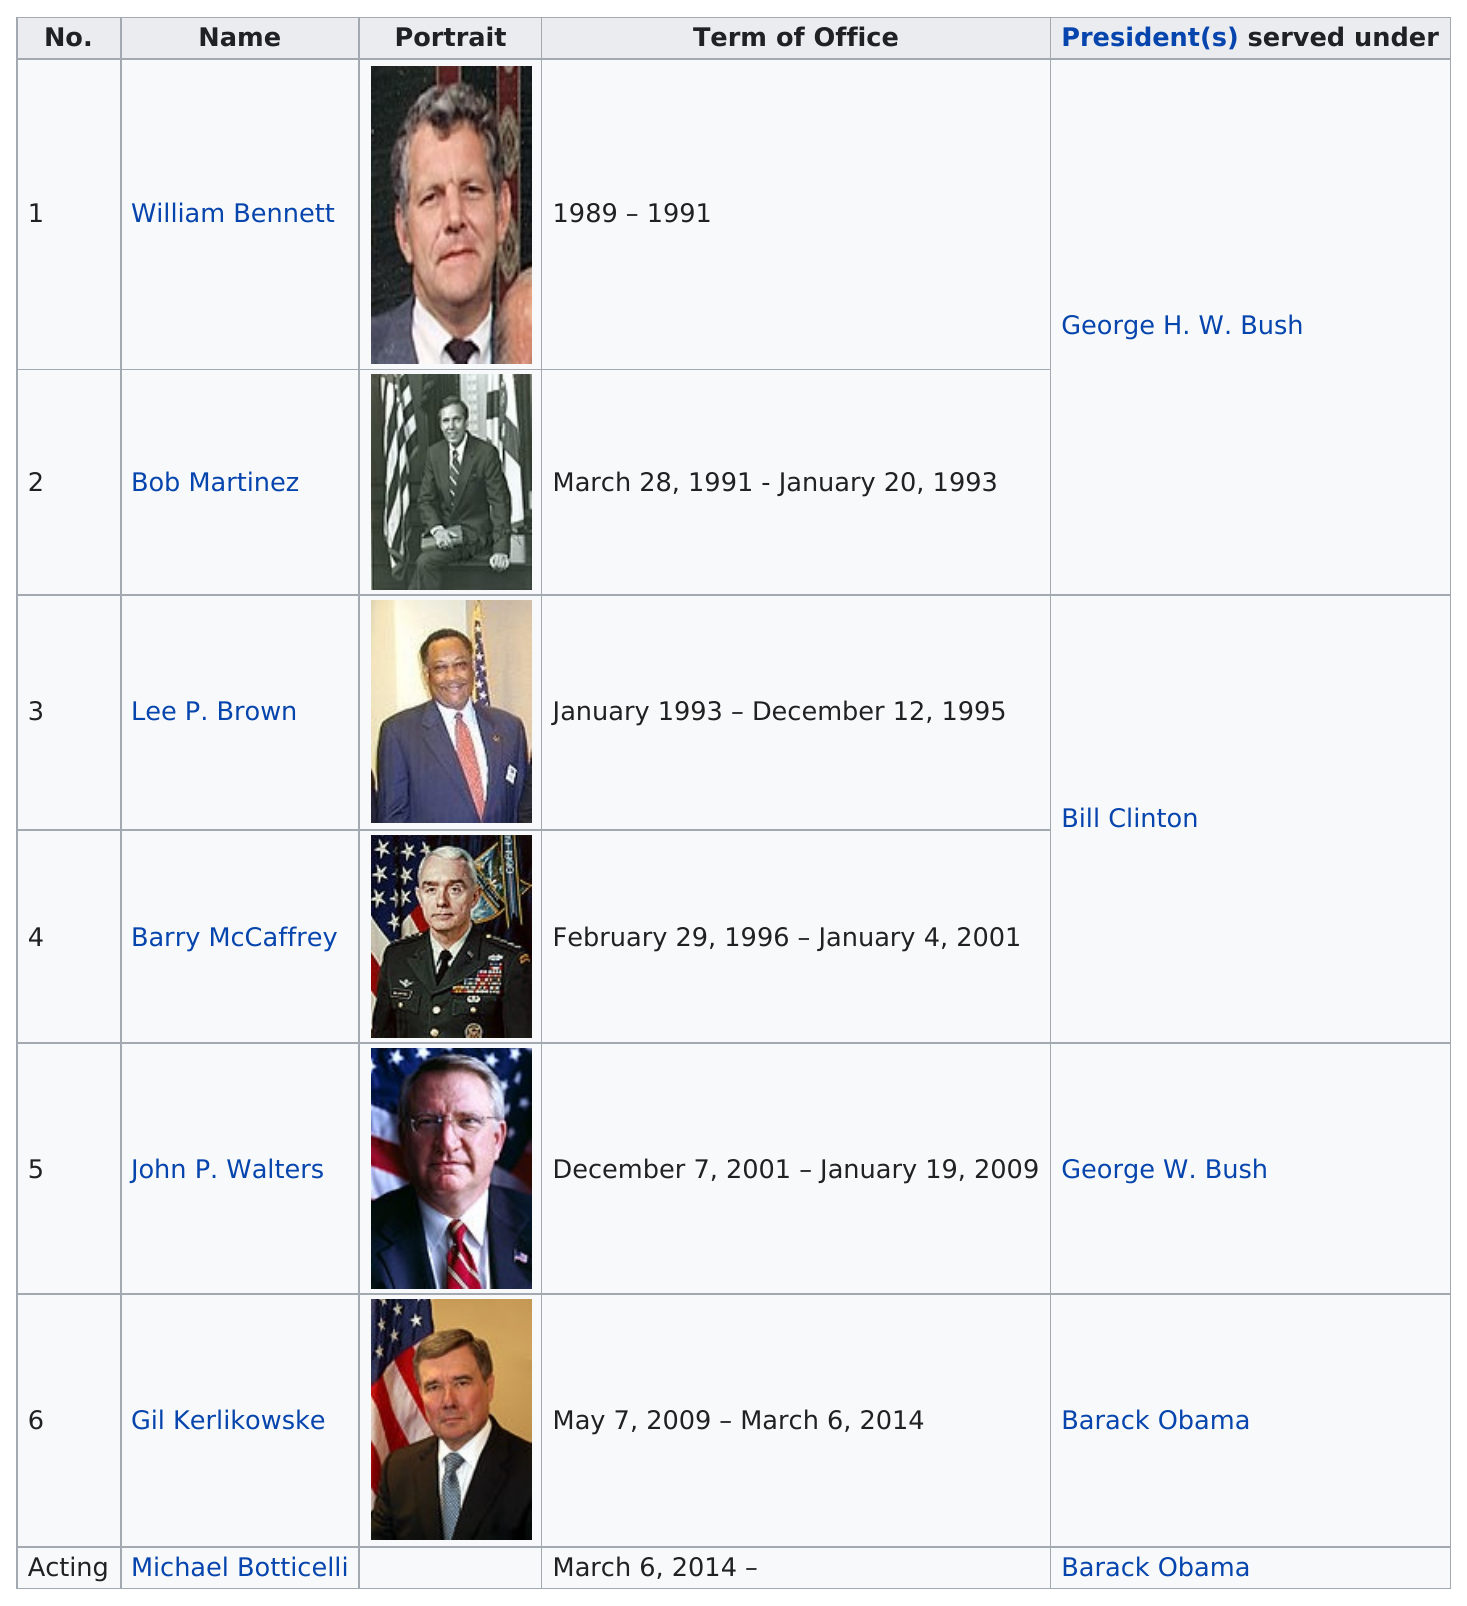Draw attention to some important aspects in this diagram. John P. Walters served the longest term as a director among all the directors listed. The total number of years Bob Martinez served in office was two. During Bill Clinton's presidency, two individuals served as directors. The first director served in office for a total of two years. After Lee P. Brown, who was appointed as the next director? Barry McCaffrey was appointed as the next director. 